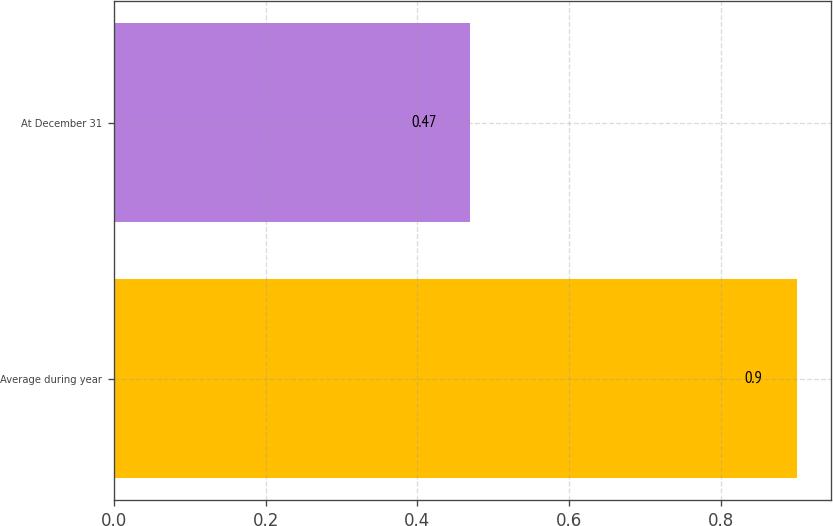Convert chart to OTSL. <chart><loc_0><loc_0><loc_500><loc_500><bar_chart><fcel>Average during year<fcel>At December 31<nl><fcel>0.9<fcel>0.47<nl></chart> 